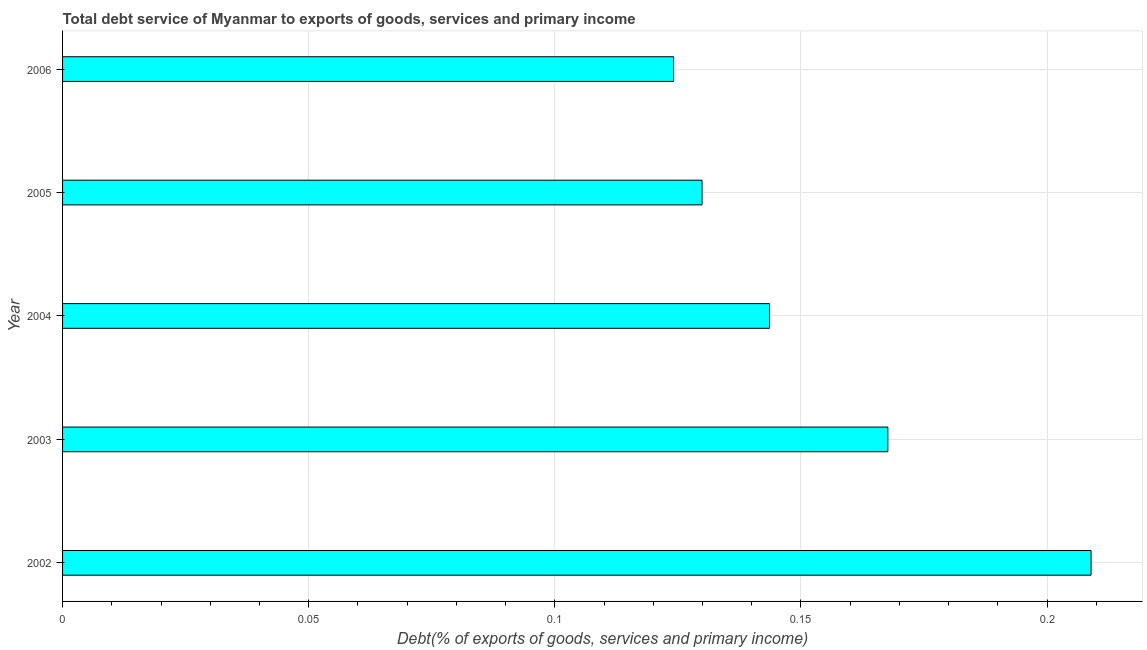What is the title of the graph?
Offer a very short reply. Total debt service of Myanmar to exports of goods, services and primary income. What is the label or title of the X-axis?
Provide a short and direct response. Debt(% of exports of goods, services and primary income). What is the label or title of the Y-axis?
Keep it short and to the point. Year. What is the total debt service in 2002?
Provide a short and direct response. 0.21. Across all years, what is the maximum total debt service?
Make the answer very short. 0.21. Across all years, what is the minimum total debt service?
Make the answer very short. 0.12. In which year was the total debt service maximum?
Give a very brief answer. 2002. What is the sum of the total debt service?
Give a very brief answer. 0.77. What is the difference between the total debt service in 2002 and 2004?
Provide a short and direct response. 0.07. What is the average total debt service per year?
Your response must be concise. 0.15. What is the median total debt service?
Give a very brief answer. 0.14. In how many years, is the total debt service greater than 0.19 %?
Your answer should be compact. 1. Do a majority of the years between 2003 and 2005 (inclusive) have total debt service greater than 0.1 %?
Your answer should be compact. Yes. What is the ratio of the total debt service in 2003 to that in 2006?
Keep it short and to the point. 1.35. Is the difference between the total debt service in 2003 and 2006 greater than the difference between any two years?
Keep it short and to the point. No. What is the difference between the highest and the second highest total debt service?
Keep it short and to the point. 0.04. Is the sum of the total debt service in 2003 and 2005 greater than the maximum total debt service across all years?
Your response must be concise. Yes. Are all the bars in the graph horizontal?
Offer a very short reply. Yes. Are the values on the major ticks of X-axis written in scientific E-notation?
Your answer should be very brief. No. What is the Debt(% of exports of goods, services and primary income) in 2002?
Keep it short and to the point. 0.21. What is the Debt(% of exports of goods, services and primary income) in 2003?
Your answer should be compact. 0.17. What is the Debt(% of exports of goods, services and primary income) in 2004?
Ensure brevity in your answer.  0.14. What is the Debt(% of exports of goods, services and primary income) of 2005?
Your answer should be very brief. 0.13. What is the Debt(% of exports of goods, services and primary income) in 2006?
Provide a short and direct response. 0.12. What is the difference between the Debt(% of exports of goods, services and primary income) in 2002 and 2003?
Offer a terse response. 0.04. What is the difference between the Debt(% of exports of goods, services and primary income) in 2002 and 2004?
Give a very brief answer. 0.07. What is the difference between the Debt(% of exports of goods, services and primary income) in 2002 and 2005?
Give a very brief answer. 0.08. What is the difference between the Debt(% of exports of goods, services and primary income) in 2002 and 2006?
Provide a succinct answer. 0.08. What is the difference between the Debt(% of exports of goods, services and primary income) in 2003 and 2004?
Your response must be concise. 0.02. What is the difference between the Debt(% of exports of goods, services and primary income) in 2003 and 2005?
Give a very brief answer. 0.04. What is the difference between the Debt(% of exports of goods, services and primary income) in 2003 and 2006?
Give a very brief answer. 0.04. What is the difference between the Debt(% of exports of goods, services and primary income) in 2004 and 2005?
Provide a short and direct response. 0.01. What is the difference between the Debt(% of exports of goods, services and primary income) in 2004 and 2006?
Provide a short and direct response. 0.02. What is the difference between the Debt(% of exports of goods, services and primary income) in 2005 and 2006?
Offer a terse response. 0.01. What is the ratio of the Debt(% of exports of goods, services and primary income) in 2002 to that in 2003?
Make the answer very short. 1.25. What is the ratio of the Debt(% of exports of goods, services and primary income) in 2002 to that in 2004?
Your answer should be very brief. 1.46. What is the ratio of the Debt(% of exports of goods, services and primary income) in 2002 to that in 2005?
Your response must be concise. 1.61. What is the ratio of the Debt(% of exports of goods, services and primary income) in 2002 to that in 2006?
Provide a short and direct response. 1.68. What is the ratio of the Debt(% of exports of goods, services and primary income) in 2003 to that in 2004?
Your response must be concise. 1.17. What is the ratio of the Debt(% of exports of goods, services and primary income) in 2003 to that in 2005?
Provide a short and direct response. 1.29. What is the ratio of the Debt(% of exports of goods, services and primary income) in 2003 to that in 2006?
Offer a very short reply. 1.35. What is the ratio of the Debt(% of exports of goods, services and primary income) in 2004 to that in 2005?
Keep it short and to the point. 1.1. What is the ratio of the Debt(% of exports of goods, services and primary income) in 2004 to that in 2006?
Offer a terse response. 1.16. What is the ratio of the Debt(% of exports of goods, services and primary income) in 2005 to that in 2006?
Provide a succinct answer. 1.05. 